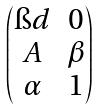Convert formula to latex. <formula><loc_0><loc_0><loc_500><loc_500>\begin{pmatrix} \i d & 0 \\ A & \beta \\ \alpha & 1 \end{pmatrix}</formula> 